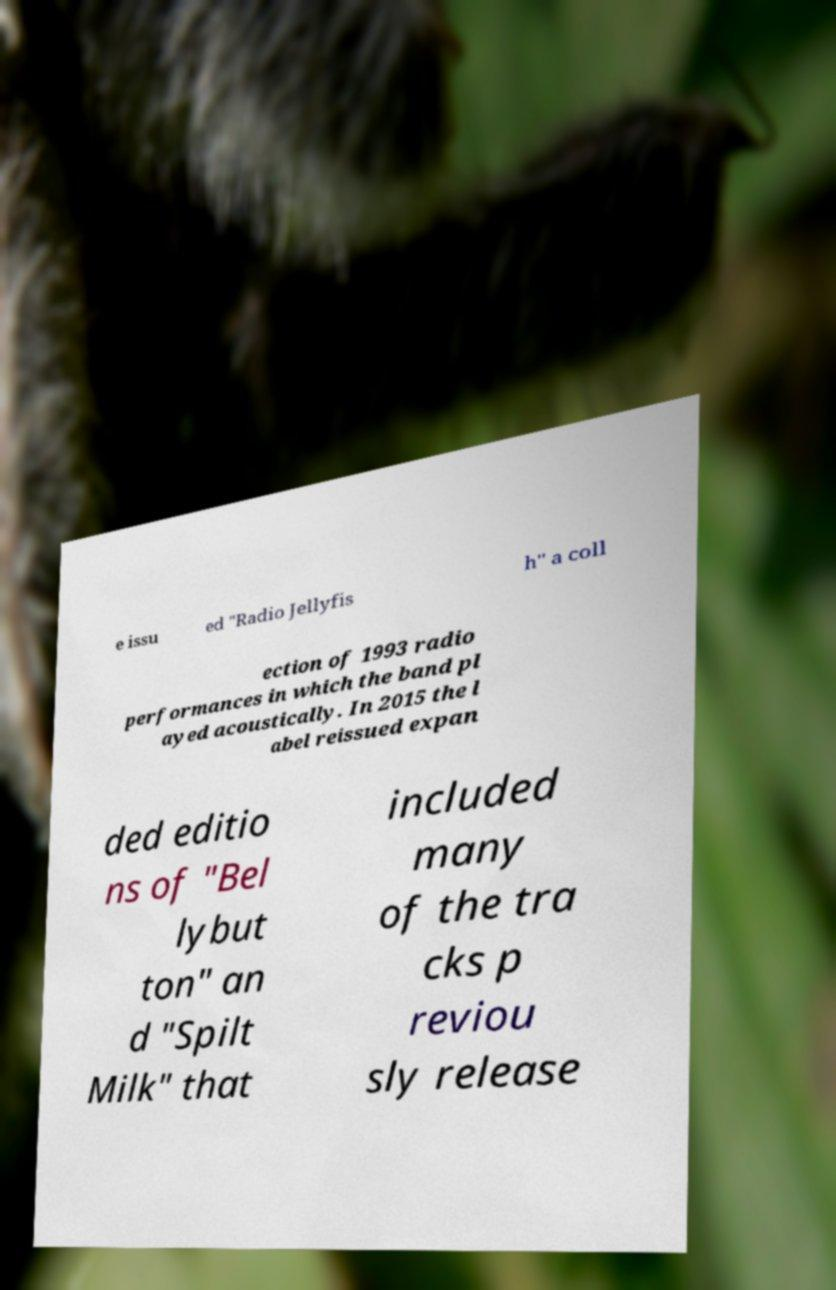Can you read and provide the text displayed in the image?This photo seems to have some interesting text. Can you extract and type it out for me? e issu ed "Radio Jellyfis h" a coll ection of 1993 radio performances in which the band pl ayed acoustically. In 2015 the l abel reissued expan ded editio ns of "Bel lybut ton" an d "Spilt Milk" that included many of the tra cks p reviou sly release 